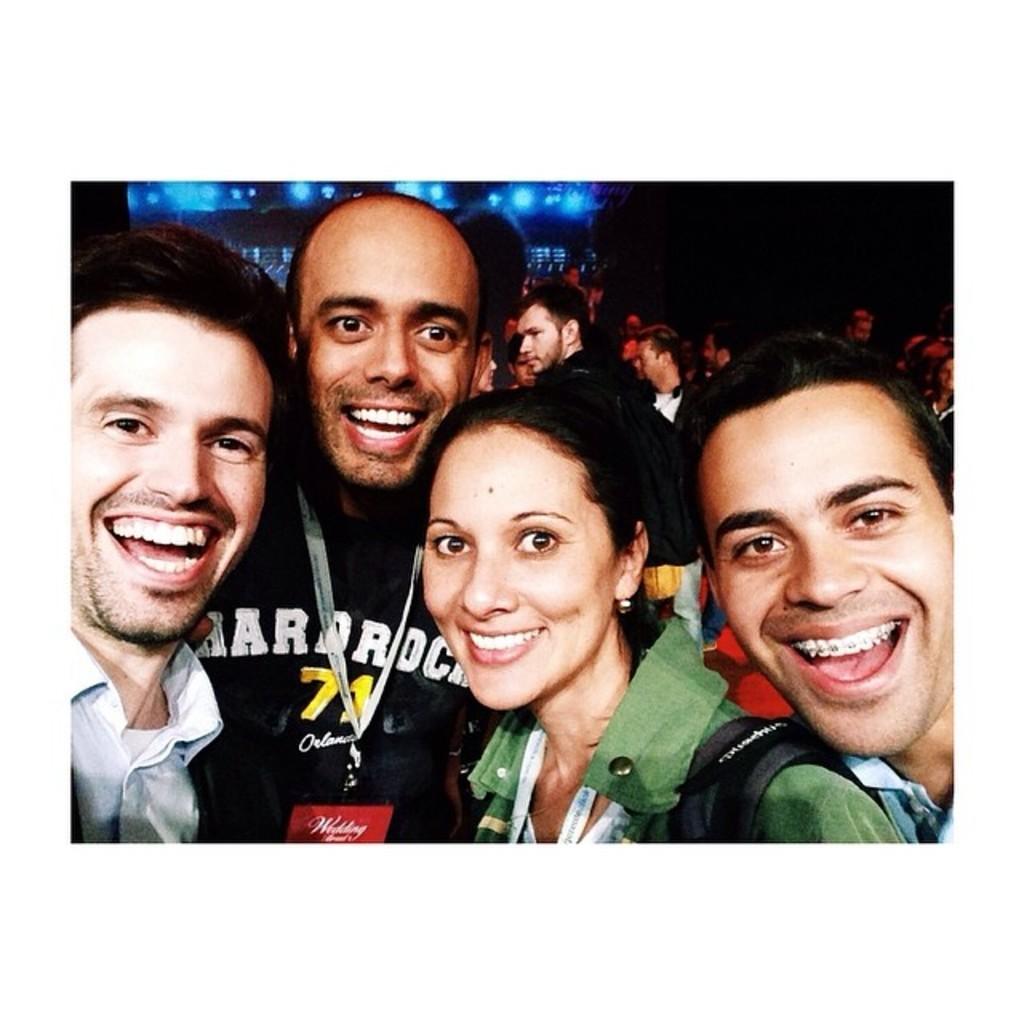How would you summarize this image in a sentence or two? There are four persons in different color dresses, smiling. In the background, there are other persons and there are blue color lights. And the background is dark in color. 